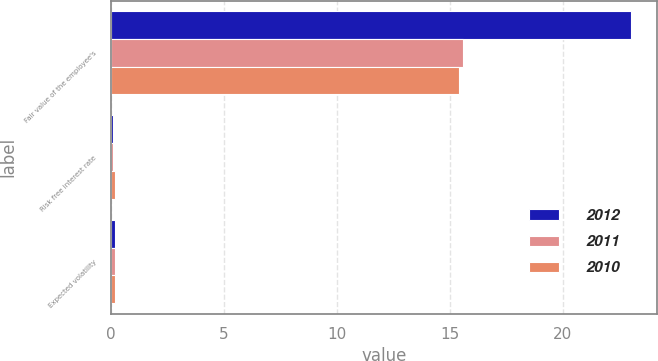Convert chart to OTSL. <chart><loc_0><loc_0><loc_500><loc_500><stacked_bar_chart><ecel><fcel>Fair value of the employee's<fcel>Risk free interest rate<fcel>Expected volatility<nl><fcel>2012<fcel>23.02<fcel>0.1<fcel>0.2<nl><fcel>2011<fcel>15.58<fcel>0.1<fcel>0.2<nl><fcel>2010<fcel>15.39<fcel>0.2<fcel>0.2<nl></chart> 